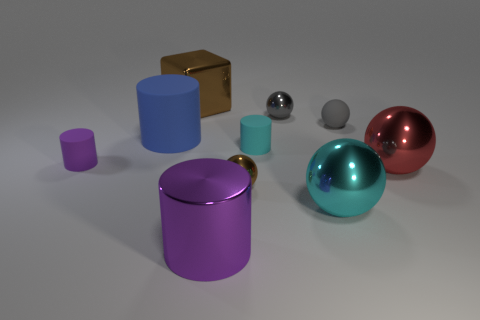Subtract all cyan rubber cylinders. How many cylinders are left? 3 Subtract all purple cylinders. How many cylinders are left? 2 Subtract all blocks. How many objects are left? 9 Subtract 2 spheres. How many spheres are left? 3 Subtract all gray cylinders. How many blue spheres are left? 0 Add 4 red things. How many red things exist? 5 Subtract 0 yellow cubes. How many objects are left? 10 Subtract all cyan cylinders. Subtract all gray cubes. How many cylinders are left? 3 Subtract all small gray spheres. Subtract all purple matte objects. How many objects are left? 7 Add 4 big blue matte things. How many big blue matte things are left? 5 